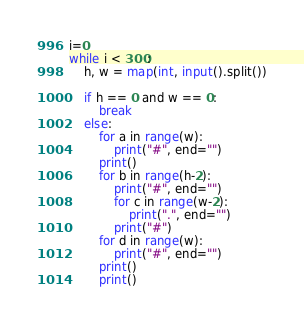Convert code to text. <code><loc_0><loc_0><loc_500><loc_500><_Python_>i=0
while i < 300:
    h, w = map(int, input().split())
    
    if h == 0 and w == 0:
        break
    else:
        for a in range(w):
            print("#", end="")
        print()
        for b in range(h-2):
            print("#", end="")
            for c in range(w-2):
                print(".", end="")
            print("#")
        for d in range(w):
            print("#", end="")
        print()
        print()

</code> 